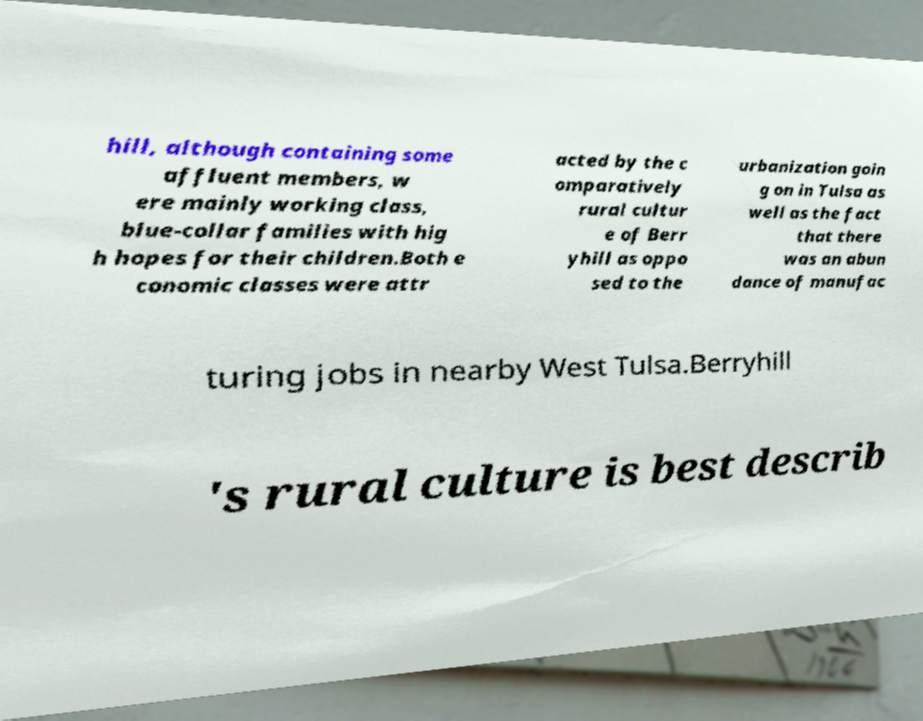What messages or text are displayed in this image? I need them in a readable, typed format. hill, although containing some affluent members, w ere mainly working class, blue-collar families with hig h hopes for their children.Both e conomic classes were attr acted by the c omparatively rural cultur e of Berr yhill as oppo sed to the urbanization goin g on in Tulsa as well as the fact that there was an abun dance of manufac turing jobs in nearby West Tulsa.Berryhill 's rural culture is best describ 